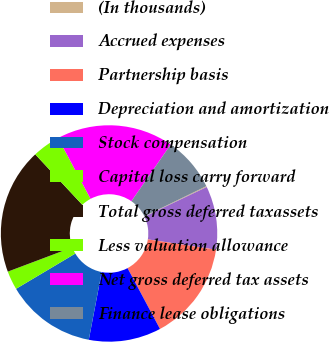<chart> <loc_0><loc_0><loc_500><loc_500><pie_chart><fcel>(In thousands)<fcel>Accrued expenses<fcel>Partnership basis<fcel>Depreciation and amortization<fcel>Stock compensation<fcel>Capital loss carry forward<fcel>Total gross deferred taxassets<fcel>Less valuation allowance<fcel>Net gross deferred tax assets<fcel>Finance lease obligations<nl><fcel>0.14%<fcel>9.47%<fcel>14.8%<fcel>10.8%<fcel>13.46%<fcel>2.81%<fcel>18.79%<fcel>4.14%<fcel>17.46%<fcel>8.14%<nl></chart> 